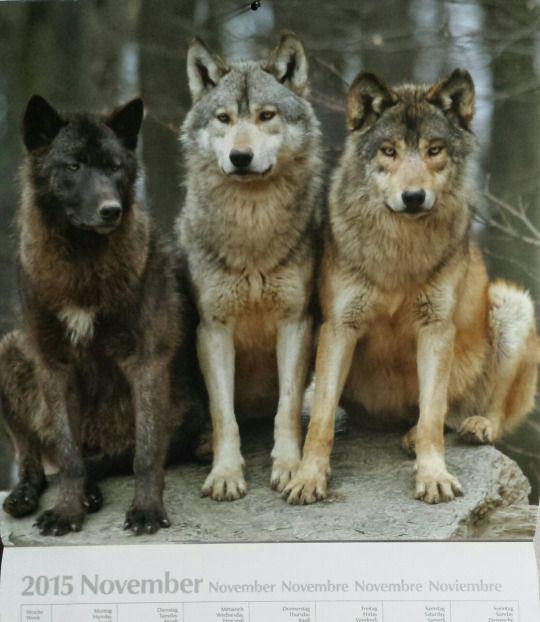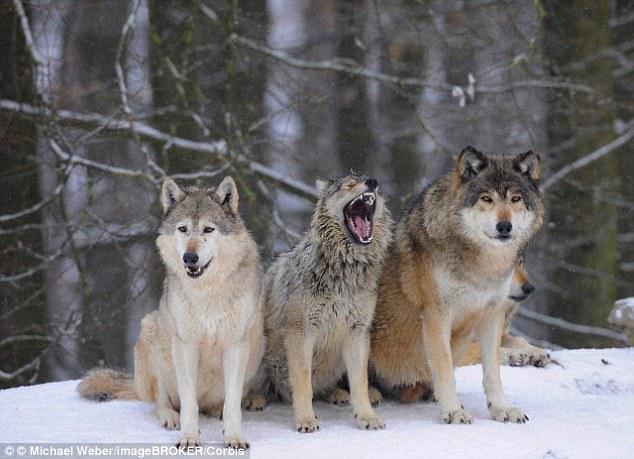The first image is the image on the left, the second image is the image on the right. Given the left and right images, does the statement "there are 4 wolves in the image pair" hold true? Answer yes or no. No. The first image is the image on the left, the second image is the image on the right. Analyze the images presented: Is the assertion "There are at least six wolves." valid? Answer yes or no. Yes. 